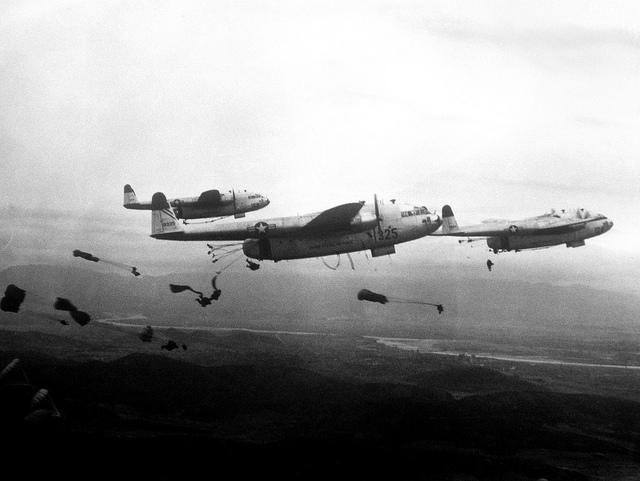How many planes are flying?
Concise answer only. 3. What are these planes dropping?
Keep it brief. Bombs. Is this an old picture?
Be succinct. Yes. Are these commercial aircraft?
Write a very short answer. No. 